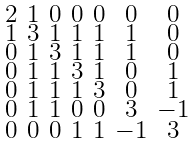<formula> <loc_0><loc_0><loc_500><loc_500>\begin{smallmatrix} 2 & 1 & 0 & 0 & 0 & 0 & 0 \\ 1 & 3 & 1 & 1 & 1 & 1 & 0 \\ 0 & 1 & 3 & 1 & 1 & 1 & 0 \\ 0 & 1 & 1 & 3 & 1 & 0 & 1 \\ 0 & 1 & 1 & 1 & 3 & 0 & 1 \\ 0 & 1 & 1 & 0 & 0 & 3 & - 1 \\ 0 & 0 & 0 & 1 & 1 & - 1 & 3 \end{smallmatrix}</formula> 